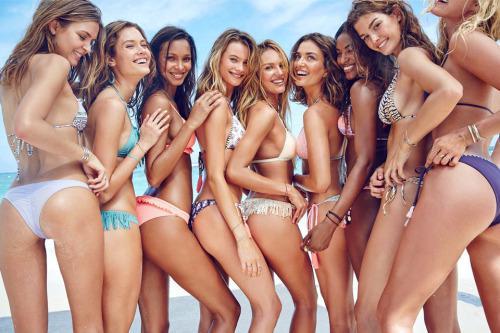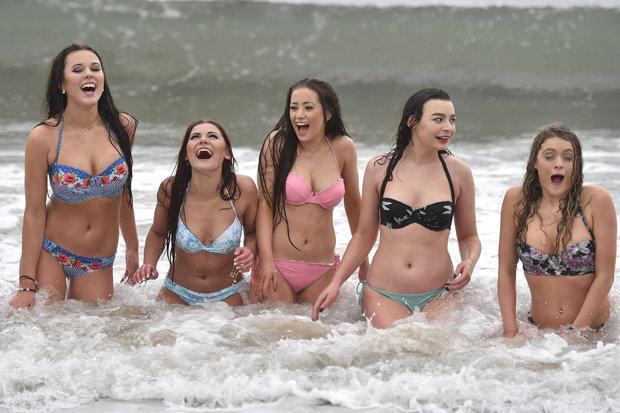The first image is the image on the left, the second image is the image on the right. Evaluate the accuracy of this statement regarding the images: "There are exactly three girls standing in one of the images.". Is it true? Answer yes or no. No. The first image is the image on the left, the second image is the image on the right. Evaluate the accuracy of this statement regarding the images: "In at least one image there are five women in bikinis in a row.". Is it true? Answer yes or no. Yes. 